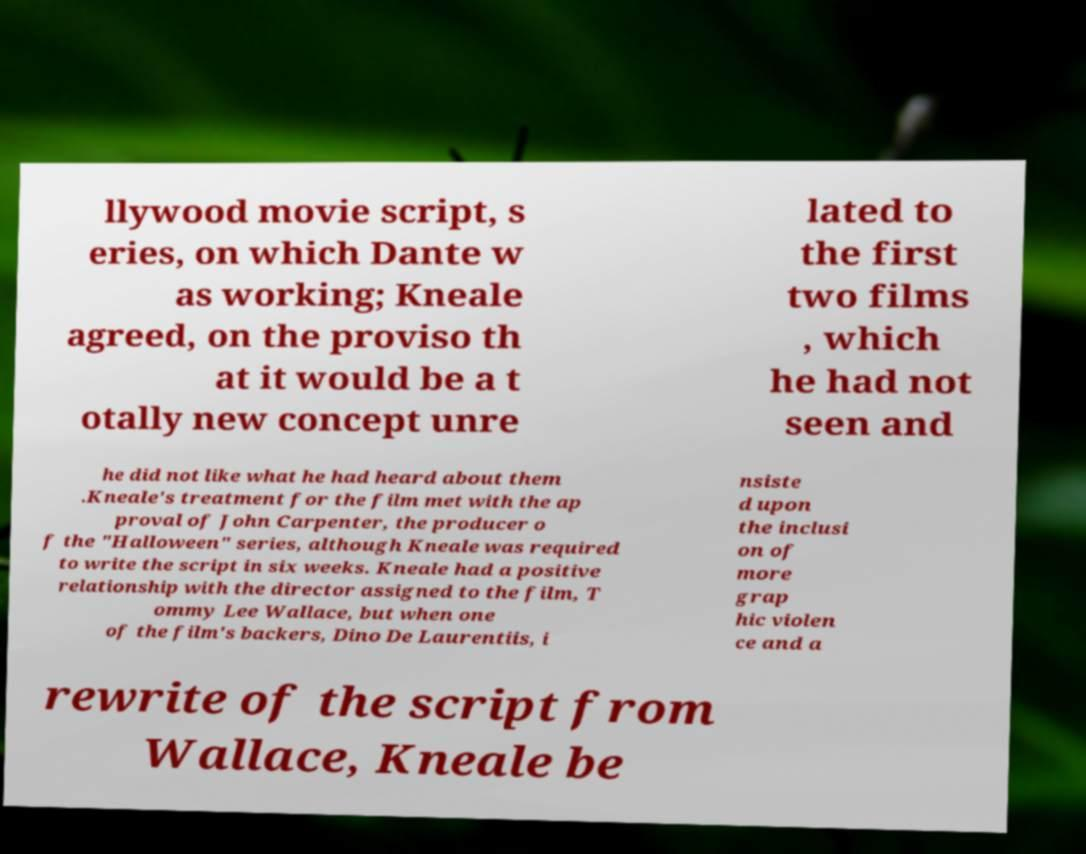For documentation purposes, I need the text within this image transcribed. Could you provide that? llywood movie script, s eries, on which Dante w as working; Kneale agreed, on the proviso th at it would be a t otally new concept unre lated to the first two films , which he had not seen and he did not like what he had heard about them .Kneale's treatment for the film met with the ap proval of John Carpenter, the producer o f the "Halloween" series, although Kneale was required to write the script in six weeks. Kneale had a positive relationship with the director assigned to the film, T ommy Lee Wallace, but when one of the film's backers, Dino De Laurentiis, i nsiste d upon the inclusi on of more grap hic violen ce and a rewrite of the script from Wallace, Kneale be 